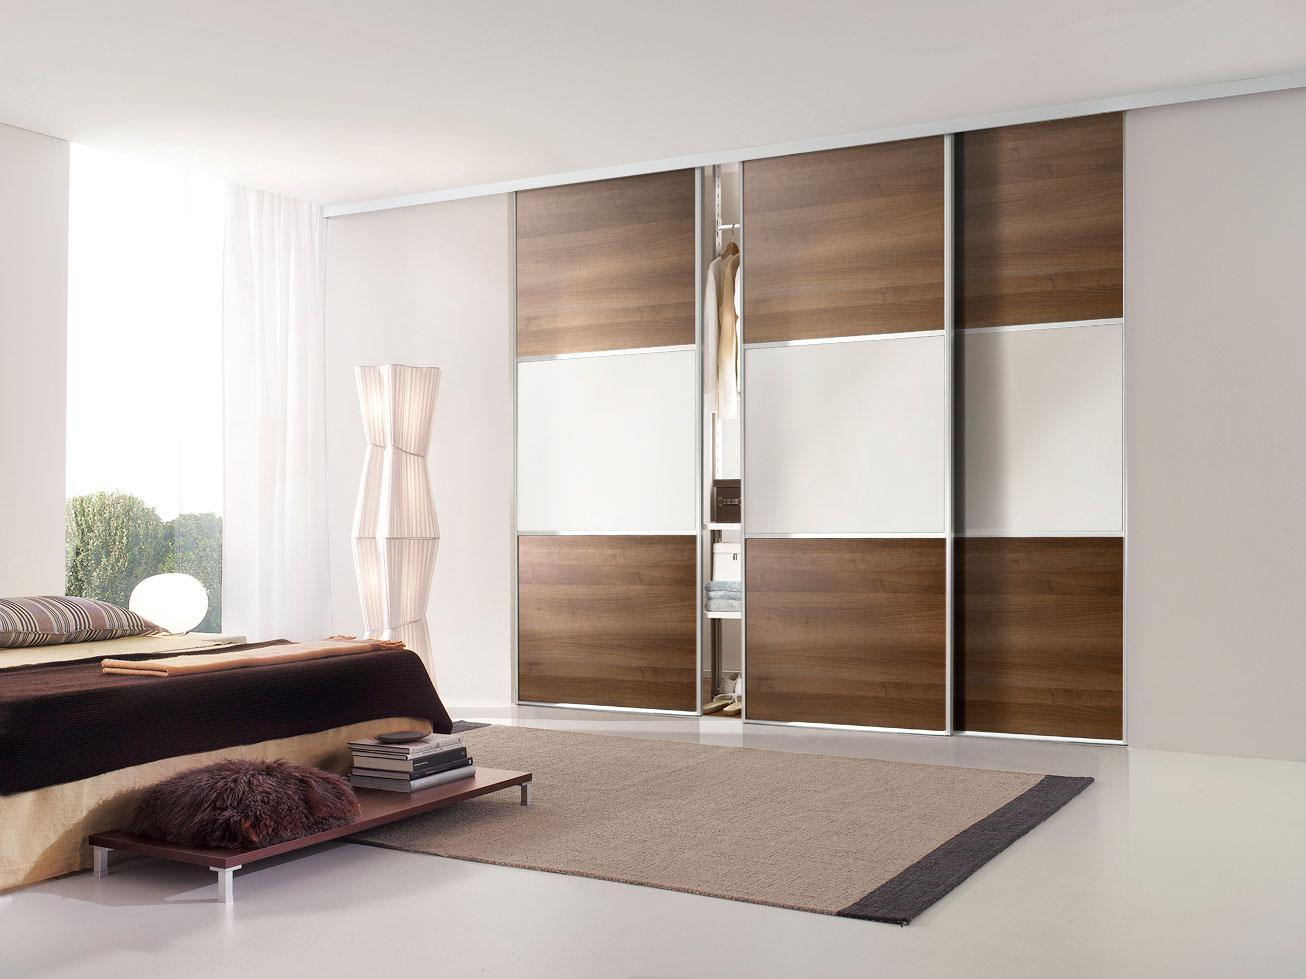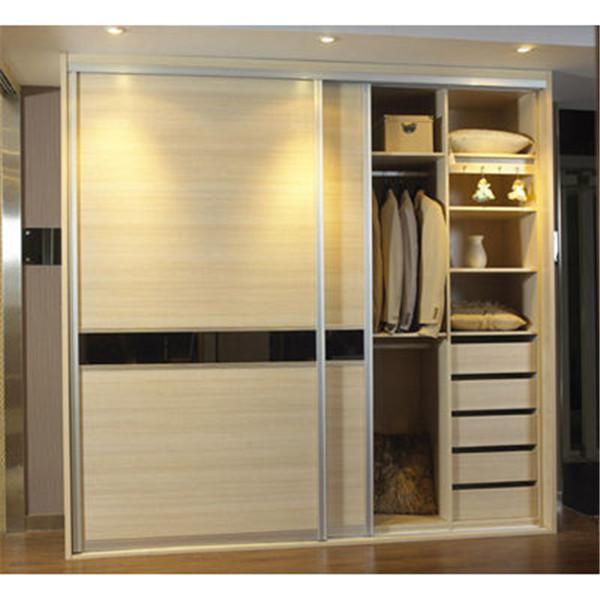The first image is the image on the left, the second image is the image on the right. Examine the images to the left and right. Is the description "In one of the images there are clothes visible inside the partially open closet." accurate? Answer yes or no. Yes. The first image is the image on the left, the second image is the image on the right. Assess this claim about the two images: "A rug covers the floor in at least one of the images.". Correct or not? Answer yes or no. Yes. 